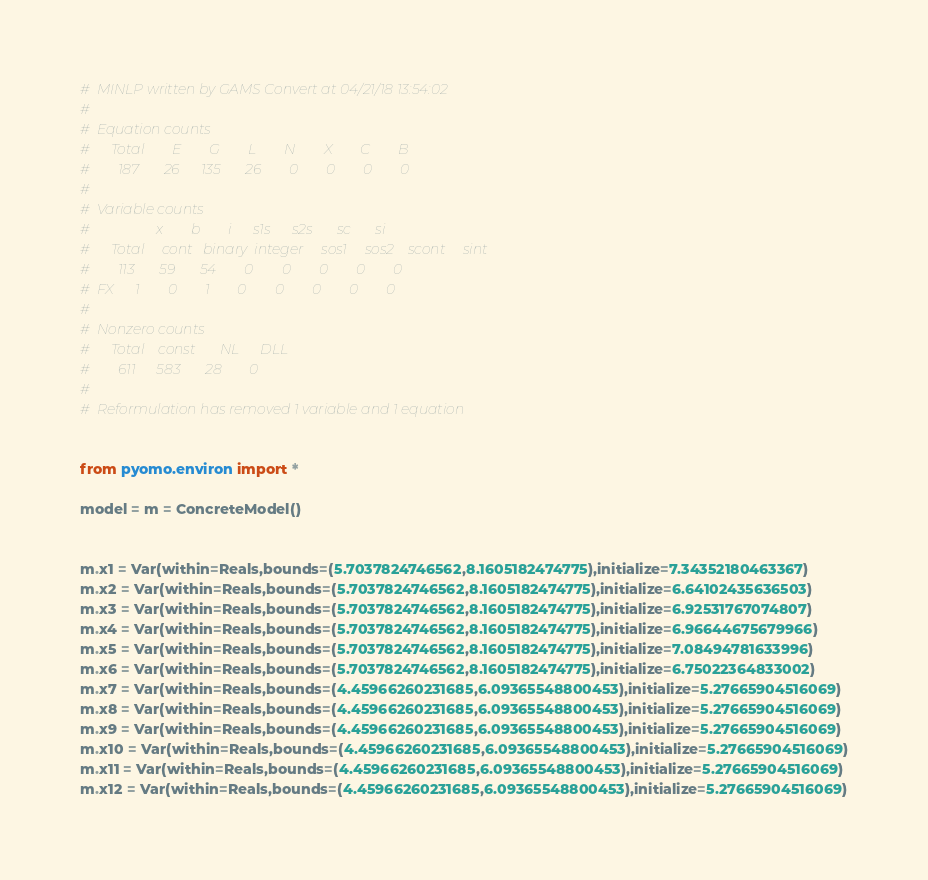Convert code to text. <code><loc_0><loc_0><loc_500><loc_500><_Python_>#  MINLP written by GAMS Convert at 04/21/18 13:54:02
#  
#  Equation counts
#      Total        E        G        L        N        X        C        B
#        187       26      135       26        0        0        0        0
#  
#  Variable counts
#                   x        b        i      s1s      s2s       sc       si
#      Total     cont   binary  integer     sos1     sos2    scont     sint
#        113       59       54        0        0        0        0        0
#  FX      1        0        1        0        0        0        0        0
#  
#  Nonzero counts
#      Total    const       NL      DLL
#        611      583       28        0
# 
#  Reformulation has removed 1 variable and 1 equation


from pyomo.environ import *

model = m = ConcreteModel()


m.x1 = Var(within=Reals,bounds=(5.7037824746562,8.1605182474775),initialize=7.34352180463367)
m.x2 = Var(within=Reals,bounds=(5.7037824746562,8.1605182474775),initialize=6.64102435636503)
m.x3 = Var(within=Reals,bounds=(5.7037824746562,8.1605182474775),initialize=6.92531767074807)
m.x4 = Var(within=Reals,bounds=(5.7037824746562,8.1605182474775),initialize=6.96644675679966)
m.x5 = Var(within=Reals,bounds=(5.7037824746562,8.1605182474775),initialize=7.08494781633996)
m.x6 = Var(within=Reals,bounds=(5.7037824746562,8.1605182474775),initialize=6.75022364833002)
m.x7 = Var(within=Reals,bounds=(4.45966260231685,6.09365548800453),initialize=5.27665904516069)
m.x8 = Var(within=Reals,bounds=(4.45966260231685,6.09365548800453),initialize=5.27665904516069)
m.x9 = Var(within=Reals,bounds=(4.45966260231685,6.09365548800453),initialize=5.27665904516069)
m.x10 = Var(within=Reals,bounds=(4.45966260231685,6.09365548800453),initialize=5.27665904516069)
m.x11 = Var(within=Reals,bounds=(4.45966260231685,6.09365548800453),initialize=5.27665904516069)
m.x12 = Var(within=Reals,bounds=(4.45966260231685,6.09365548800453),initialize=5.27665904516069)</code> 